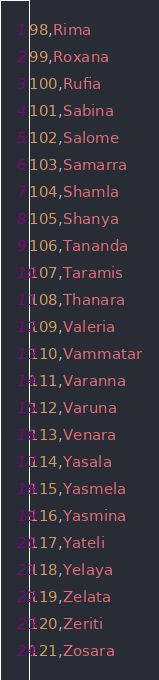<code> <loc_0><loc_0><loc_500><loc_500><_SQL_>98,Rima
99,Roxana
100,Rufia
101,Sabina
102,Salome
103,Samarra
104,Shamla
105,Shanya
106,Tananda
107,Taramis
108,Thanara
109,Valeria
110,Vammatar
111,Varanna
112,Varuna
113,Venara
114,Yasala
115,Yasmela
116,Yasmina
117,Yateli
118,Yelaya
119,Zelata
120,Zeriti
121,Zosara

</code> 